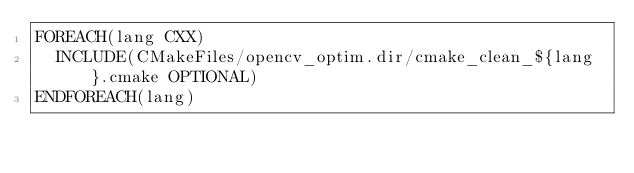<code> <loc_0><loc_0><loc_500><loc_500><_CMake_>FOREACH(lang CXX)
  INCLUDE(CMakeFiles/opencv_optim.dir/cmake_clean_${lang}.cmake OPTIONAL)
ENDFOREACH(lang)
</code> 